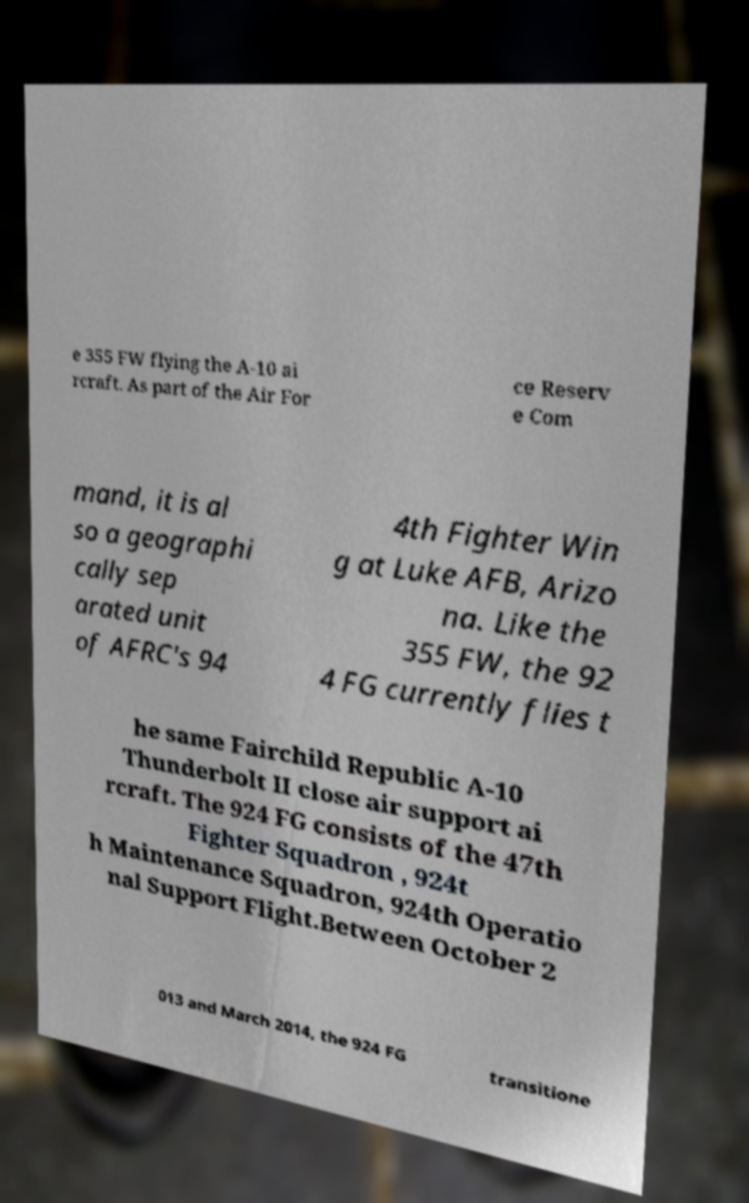Could you assist in decoding the text presented in this image and type it out clearly? e 355 FW flying the A-10 ai rcraft. As part of the Air For ce Reserv e Com mand, it is al so a geographi cally sep arated unit of AFRC's 94 4th Fighter Win g at Luke AFB, Arizo na. Like the 355 FW, the 92 4 FG currently flies t he same Fairchild Republic A-10 Thunderbolt II close air support ai rcraft. The 924 FG consists of the 47th Fighter Squadron , 924t h Maintenance Squadron, 924th Operatio nal Support Flight.Between October 2 013 and March 2014, the 924 FG transitione 